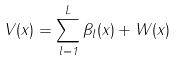<formula> <loc_0><loc_0><loc_500><loc_500>V ( x ) = \sum _ { l = 1 } ^ { L } \beta _ { l } ( x ) + W ( x )</formula> 